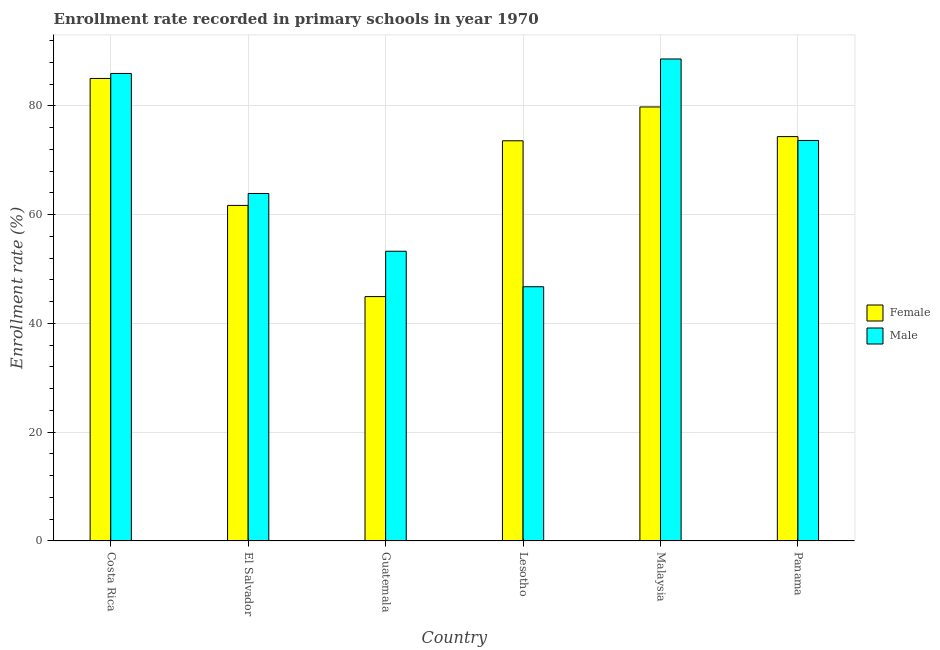How many different coloured bars are there?
Ensure brevity in your answer.  2. How many groups of bars are there?
Make the answer very short. 6. How many bars are there on the 1st tick from the right?
Your answer should be compact. 2. What is the enrollment rate of female students in Costa Rica?
Ensure brevity in your answer.  85.03. Across all countries, what is the maximum enrollment rate of male students?
Provide a succinct answer. 88.61. Across all countries, what is the minimum enrollment rate of female students?
Keep it short and to the point. 44.93. In which country was the enrollment rate of male students maximum?
Your response must be concise. Malaysia. In which country was the enrollment rate of male students minimum?
Your answer should be compact. Lesotho. What is the total enrollment rate of male students in the graph?
Keep it short and to the point. 412.08. What is the difference between the enrollment rate of female students in Lesotho and that in Malaysia?
Your answer should be compact. -6.22. What is the difference between the enrollment rate of female students in Lesotho and the enrollment rate of male students in Costa Rica?
Ensure brevity in your answer.  -12.38. What is the average enrollment rate of female students per country?
Your response must be concise. 69.89. What is the difference between the enrollment rate of male students and enrollment rate of female students in Lesotho?
Provide a succinct answer. -26.83. In how many countries, is the enrollment rate of male students greater than 88 %?
Offer a terse response. 1. What is the ratio of the enrollment rate of female students in Lesotho to that in Malaysia?
Make the answer very short. 0.92. Is the difference between the enrollment rate of female students in El Salvador and Guatemala greater than the difference between the enrollment rate of male students in El Salvador and Guatemala?
Offer a very short reply. Yes. What is the difference between the highest and the second highest enrollment rate of female students?
Your answer should be very brief. 5.24. What is the difference between the highest and the lowest enrollment rate of male students?
Keep it short and to the point. 41.87. What does the 2nd bar from the left in Lesotho represents?
Keep it short and to the point. Male. How many bars are there?
Give a very brief answer. 12. Are all the bars in the graph horizontal?
Offer a terse response. No. What is the difference between two consecutive major ticks on the Y-axis?
Offer a very short reply. 20. Are the values on the major ticks of Y-axis written in scientific E-notation?
Keep it short and to the point. No. Does the graph contain grids?
Provide a succinct answer. Yes. Where does the legend appear in the graph?
Offer a terse response. Center right. How are the legend labels stacked?
Offer a terse response. Vertical. What is the title of the graph?
Keep it short and to the point. Enrollment rate recorded in primary schools in year 1970. Does "Diarrhea" appear as one of the legend labels in the graph?
Keep it short and to the point. No. What is the label or title of the X-axis?
Keep it short and to the point. Country. What is the label or title of the Y-axis?
Offer a terse response. Enrollment rate (%). What is the Enrollment rate (%) of Female in Costa Rica?
Offer a terse response. 85.03. What is the Enrollment rate (%) of Male in Costa Rica?
Your response must be concise. 85.95. What is the Enrollment rate (%) of Female in El Salvador?
Keep it short and to the point. 61.69. What is the Enrollment rate (%) of Male in El Salvador?
Offer a very short reply. 63.88. What is the Enrollment rate (%) of Female in Guatemala?
Offer a terse response. 44.93. What is the Enrollment rate (%) of Male in Guatemala?
Ensure brevity in your answer.  53.27. What is the Enrollment rate (%) in Female in Lesotho?
Offer a terse response. 73.57. What is the Enrollment rate (%) of Male in Lesotho?
Your answer should be very brief. 46.74. What is the Enrollment rate (%) of Female in Malaysia?
Provide a succinct answer. 79.79. What is the Enrollment rate (%) in Male in Malaysia?
Provide a succinct answer. 88.61. What is the Enrollment rate (%) in Female in Panama?
Your response must be concise. 74.34. What is the Enrollment rate (%) in Male in Panama?
Make the answer very short. 73.63. Across all countries, what is the maximum Enrollment rate (%) in Female?
Keep it short and to the point. 85.03. Across all countries, what is the maximum Enrollment rate (%) of Male?
Your response must be concise. 88.61. Across all countries, what is the minimum Enrollment rate (%) of Female?
Your answer should be very brief. 44.93. Across all countries, what is the minimum Enrollment rate (%) of Male?
Your answer should be very brief. 46.74. What is the total Enrollment rate (%) of Female in the graph?
Your answer should be compact. 419.36. What is the total Enrollment rate (%) in Male in the graph?
Make the answer very short. 412.08. What is the difference between the Enrollment rate (%) of Female in Costa Rica and that in El Salvador?
Offer a terse response. 23.34. What is the difference between the Enrollment rate (%) in Male in Costa Rica and that in El Salvador?
Provide a succinct answer. 22.07. What is the difference between the Enrollment rate (%) in Female in Costa Rica and that in Guatemala?
Make the answer very short. 40.1. What is the difference between the Enrollment rate (%) of Male in Costa Rica and that in Guatemala?
Provide a short and direct response. 32.69. What is the difference between the Enrollment rate (%) of Female in Costa Rica and that in Lesotho?
Ensure brevity in your answer.  11.46. What is the difference between the Enrollment rate (%) in Male in Costa Rica and that in Lesotho?
Provide a short and direct response. 39.21. What is the difference between the Enrollment rate (%) of Female in Costa Rica and that in Malaysia?
Offer a very short reply. 5.24. What is the difference between the Enrollment rate (%) in Male in Costa Rica and that in Malaysia?
Offer a terse response. -2.66. What is the difference between the Enrollment rate (%) in Female in Costa Rica and that in Panama?
Keep it short and to the point. 10.69. What is the difference between the Enrollment rate (%) in Male in Costa Rica and that in Panama?
Offer a very short reply. 12.32. What is the difference between the Enrollment rate (%) in Female in El Salvador and that in Guatemala?
Your answer should be very brief. 16.76. What is the difference between the Enrollment rate (%) of Male in El Salvador and that in Guatemala?
Ensure brevity in your answer.  10.62. What is the difference between the Enrollment rate (%) of Female in El Salvador and that in Lesotho?
Provide a succinct answer. -11.88. What is the difference between the Enrollment rate (%) of Male in El Salvador and that in Lesotho?
Make the answer very short. 17.15. What is the difference between the Enrollment rate (%) in Female in El Salvador and that in Malaysia?
Provide a succinct answer. -18.1. What is the difference between the Enrollment rate (%) in Male in El Salvador and that in Malaysia?
Offer a very short reply. -24.73. What is the difference between the Enrollment rate (%) of Female in El Salvador and that in Panama?
Offer a terse response. -12.65. What is the difference between the Enrollment rate (%) of Male in El Salvador and that in Panama?
Ensure brevity in your answer.  -9.75. What is the difference between the Enrollment rate (%) in Female in Guatemala and that in Lesotho?
Offer a very short reply. -28.64. What is the difference between the Enrollment rate (%) of Male in Guatemala and that in Lesotho?
Offer a terse response. 6.53. What is the difference between the Enrollment rate (%) in Female in Guatemala and that in Malaysia?
Offer a very short reply. -34.86. What is the difference between the Enrollment rate (%) in Male in Guatemala and that in Malaysia?
Offer a terse response. -35.35. What is the difference between the Enrollment rate (%) of Female in Guatemala and that in Panama?
Your answer should be very brief. -29.41. What is the difference between the Enrollment rate (%) in Male in Guatemala and that in Panama?
Keep it short and to the point. -20.37. What is the difference between the Enrollment rate (%) of Female in Lesotho and that in Malaysia?
Make the answer very short. -6.22. What is the difference between the Enrollment rate (%) of Male in Lesotho and that in Malaysia?
Provide a short and direct response. -41.87. What is the difference between the Enrollment rate (%) in Female in Lesotho and that in Panama?
Your answer should be compact. -0.77. What is the difference between the Enrollment rate (%) of Male in Lesotho and that in Panama?
Your answer should be very brief. -26.89. What is the difference between the Enrollment rate (%) of Female in Malaysia and that in Panama?
Make the answer very short. 5.45. What is the difference between the Enrollment rate (%) of Male in Malaysia and that in Panama?
Make the answer very short. 14.98. What is the difference between the Enrollment rate (%) in Female in Costa Rica and the Enrollment rate (%) in Male in El Salvador?
Give a very brief answer. 21.15. What is the difference between the Enrollment rate (%) in Female in Costa Rica and the Enrollment rate (%) in Male in Guatemala?
Make the answer very short. 31.77. What is the difference between the Enrollment rate (%) of Female in Costa Rica and the Enrollment rate (%) of Male in Lesotho?
Make the answer very short. 38.29. What is the difference between the Enrollment rate (%) of Female in Costa Rica and the Enrollment rate (%) of Male in Malaysia?
Provide a short and direct response. -3.58. What is the difference between the Enrollment rate (%) in Female in Costa Rica and the Enrollment rate (%) in Male in Panama?
Make the answer very short. 11.4. What is the difference between the Enrollment rate (%) in Female in El Salvador and the Enrollment rate (%) in Male in Guatemala?
Provide a succinct answer. 8.43. What is the difference between the Enrollment rate (%) in Female in El Salvador and the Enrollment rate (%) in Male in Lesotho?
Give a very brief answer. 14.95. What is the difference between the Enrollment rate (%) in Female in El Salvador and the Enrollment rate (%) in Male in Malaysia?
Keep it short and to the point. -26.92. What is the difference between the Enrollment rate (%) in Female in El Salvador and the Enrollment rate (%) in Male in Panama?
Provide a short and direct response. -11.94. What is the difference between the Enrollment rate (%) of Female in Guatemala and the Enrollment rate (%) of Male in Lesotho?
Make the answer very short. -1.81. What is the difference between the Enrollment rate (%) in Female in Guatemala and the Enrollment rate (%) in Male in Malaysia?
Provide a succinct answer. -43.68. What is the difference between the Enrollment rate (%) in Female in Guatemala and the Enrollment rate (%) in Male in Panama?
Provide a short and direct response. -28.7. What is the difference between the Enrollment rate (%) of Female in Lesotho and the Enrollment rate (%) of Male in Malaysia?
Provide a short and direct response. -15.04. What is the difference between the Enrollment rate (%) in Female in Lesotho and the Enrollment rate (%) in Male in Panama?
Offer a very short reply. -0.06. What is the difference between the Enrollment rate (%) in Female in Malaysia and the Enrollment rate (%) in Male in Panama?
Your answer should be very brief. 6.16. What is the average Enrollment rate (%) in Female per country?
Your response must be concise. 69.89. What is the average Enrollment rate (%) in Male per country?
Provide a short and direct response. 68.68. What is the difference between the Enrollment rate (%) in Female and Enrollment rate (%) in Male in Costa Rica?
Ensure brevity in your answer.  -0.92. What is the difference between the Enrollment rate (%) of Female and Enrollment rate (%) of Male in El Salvador?
Keep it short and to the point. -2.19. What is the difference between the Enrollment rate (%) of Female and Enrollment rate (%) of Male in Guatemala?
Give a very brief answer. -8.34. What is the difference between the Enrollment rate (%) in Female and Enrollment rate (%) in Male in Lesotho?
Make the answer very short. 26.83. What is the difference between the Enrollment rate (%) in Female and Enrollment rate (%) in Male in Malaysia?
Make the answer very short. -8.82. What is the difference between the Enrollment rate (%) of Female and Enrollment rate (%) of Male in Panama?
Your answer should be compact. 0.71. What is the ratio of the Enrollment rate (%) in Female in Costa Rica to that in El Salvador?
Provide a succinct answer. 1.38. What is the ratio of the Enrollment rate (%) of Male in Costa Rica to that in El Salvador?
Your answer should be compact. 1.35. What is the ratio of the Enrollment rate (%) of Female in Costa Rica to that in Guatemala?
Provide a succinct answer. 1.89. What is the ratio of the Enrollment rate (%) in Male in Costa Rica to that in Guatemala?
Provide a short and direct response. 1.61. What is the ratio of the Enrollment rate (%) in Female in Costa Rica to that in Lesotho?
Offer a very short reply. 1.16. What is the ratio of the Enrollment rate (%) in Male in Costa Rica to that in Lesotho?
Offer a terse response. 1.84. What is the ratio of the Enrollment rate (%) of Female in Costa Rica to that in Malaysia?
Ensure brevity in your answer.  1.07. What is the ratio of the Enrollment rate (%) of Male in Costa Rica to that in Malaysia?
Ensure brevity in your answer.  0.97. What is the ratio of the Enrollment rate (%) of Female in Costa Rica to that in Panama?
Provide a succinct answer. 1.14. What is the ratio of the Enrollment rate (%) of Male in Costa Rica to that in Panama?
Ensure brevity in your answer.  1.17. What is the ratio of the Enrollment rate (%) in Female in El Salvador to that in Guatemala?
Offer a terse response. 1.37. What is the ratio of the Enrollment rate (%) in Male in El Salvador to that in Guatemala?
Your response must be concise. 1.2. What is the ratio of the Enrollment rate (%) in Female in El Salvador to that in Lesotho?
Keep it short and to the point. 0.84. What is the ratio of the Enrollment rate (%) of Male in El Salvador to that in Lesotho?
Ensure brevity in your answer.  1.37. What is the ratio of the Enrollment rate (%) of Female in El Salvador to that in Malaysia?
Provide a short and direct response. 0.77. What is the ratio of the Enrollment rate (%) of Male in El Salvador to that in Malaysia?
Offer a terse response. 0.72. What is the ratio of the Enrollment rate (%) in Female in El Salvador to that in Panama?
Keep it short and to the point. 0.83. What is the ratio of the Enrollment rate (%) in Male in El Salvador to that in Panama?
Ensure brevity in your answer.  0.87. What is the ratio of the Enrollment rate (%) in Female in Guatemala to that in Lesotho?
Your response must be concise. 0.61. What is the ratio of the Enrollment rate (%) in Male in Guatemala to that in Lesotho?
Your response must be concise. 1.14. What is the ratio of the Enrollment rate (%) in Female in Guatemala to that in Malaysia?
Offer a very short reply. 0.56. What is the ratio of the Enrollment rate (%) in Male in Guatemala to that in Malaysia?
Ensure brevity in your answer.  0.6. What is the ratio of the Enrollment rate (%) of Female in Guatemala to that in Panama?
Give a very brief answer. 0.6. What is the ratio of the Enrollment rate (%) in Male in Guatemala to that in Panama?
Your response must be concise. 0.72. What is the ratio of the Enrollment rate (%) of Female in Lesotho to that in Malaysia?
Your answer should be very brief. 0.92. What is the ratio of the Enrollment rate (%) in Male in Lesotho to that in Malaysia?
Provide a short and direct response. 0.53. What is the ratio of the Enrollment rate (%) in Male in Lesotho to that in Panama?
Provide a succinct answer. 0.63. What is the ratio of the Enrollment rate (%) of Female in Malaysia to that in Panama?
Keep it short and to the point. 1.07. What is the ratio of the Enrollment rate (%) in Male in Malaysia to that in Panama?
Ensure brevity in your answer.  1.2. What is the difference between the highest and the second highest Enrollment rate (%) of Female?
Offer a terse response. 5.24. What is the difference between the highest and the second highest Enrollment rate (%) in Male?
Give a very brief answer. 2.66. What is the difference between the highest and the lowest Enrollment rate (%) of Female?
Provide a short and direct response. 40.1. What is the difference between the highest and the lowest Enrollment rate (%) of Male?
Ensure brevity in your answer.  41.87. 